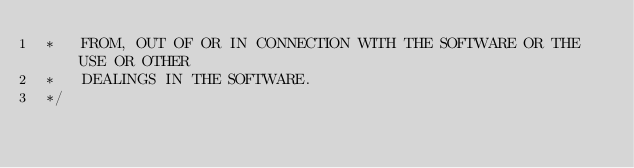<code> <loc_0><loc_0><loc_500><loc_500><_JavaScript_> *   FROM, OUT OF OR IN CONNECTION WITH THE SOFTWARE OR THE USE OR OTHER
 *   DEALINGS IN THE SOFTWARE.
 */
</code> 